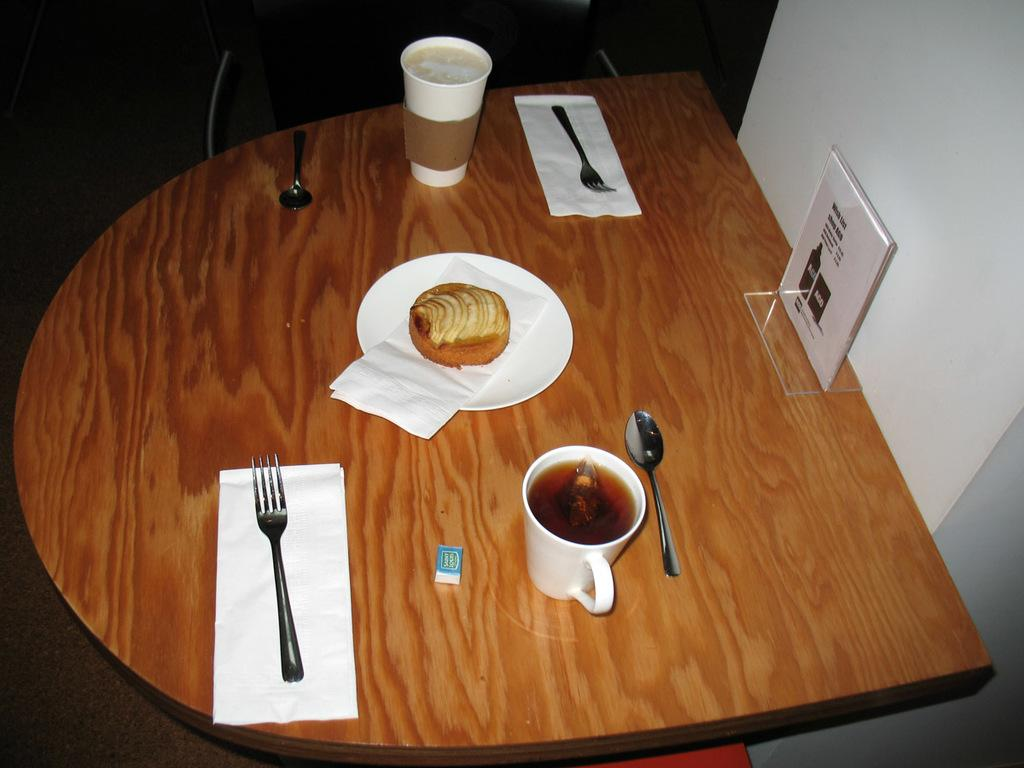What piece of furniture is present in the image? There is a table in the image. What is placed on the table? There is a plate, a fork, a spoon, a cup, and a glass on the table. What is on the plate? There is food on the plate. What can be seen in the background of the image? There is a wall visible in the image. What type of story is being told by the passenger in the image? There is no passenger present in the image, so no story can be told by a passenger. 